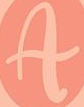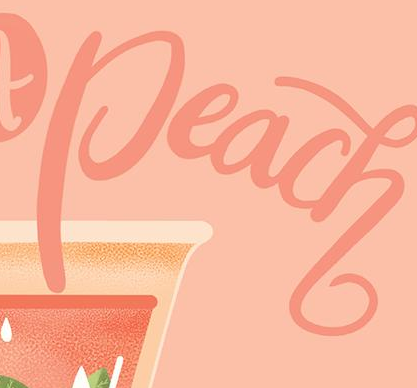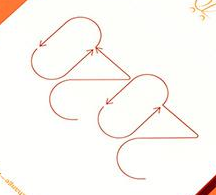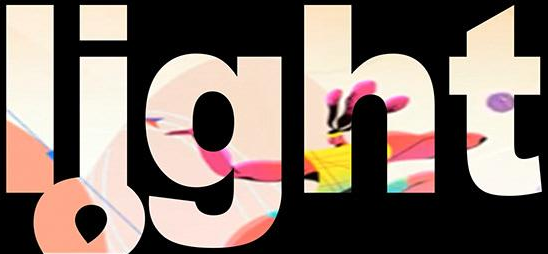Read the text from these images in sequence, separated by a semicolon. A; Peach; 2020; light 